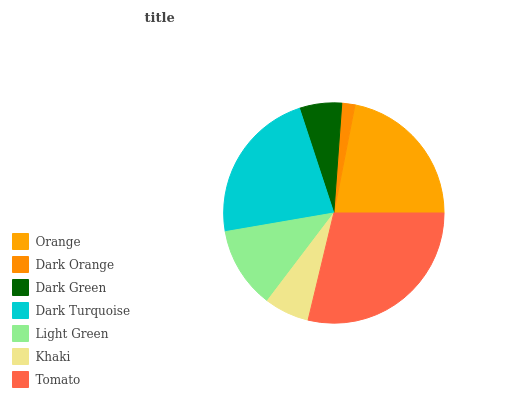Is Dark Orange the minimum?
Answer yes or no. Yes. Is Tomato the maximum?
Answer yes or no. Yes. Is Dark Green the minimum?
Answer yes or no. No. Is Dark Green the maximum?
Answer yes or no. No. Is Dark Green greater than Dark Orange?
Answer yes or no. Yes. Is Dark Orange less than Dark Green?
Answer yes or no. Yes. Is Dark Orange greater than Dark Green?
Answer yes or no. No. Is Dark Green less than Dark Orange?
Answer yes or no. No. Is Light Green the high median?
Answer yes or no. Yes. Is Light Green the low median?
Answer yes or no. Yes. Is Khaki the high median?
Answer yes or no. No. Is Dark Turquoise the low median?
Answer yes or no. No. 